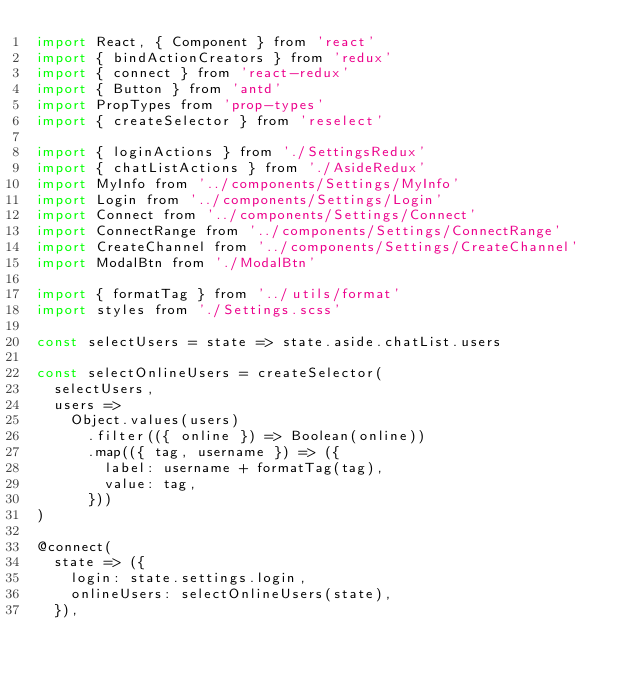<code> <loc_0><loc_0><loc_500><loc_500><_JavaScript_>import React, { Component } from 'react'
import { bindActionCreators } from 'redux'
import { connect } from 'react-redux'
import { Button } from 'antd'
import PropTypes from 'prop-types'
import { createSelector } from 'reselect'

import { loginActions } from './SettingsRedux'
import { chatListActions } from './AsideRedux'
import MyInfo from '../components/Settings/MyInfo'
import Login from '../components/Settings/Login'
import Connect from '../components/Settings/Connect'
import ConnectRange from '../components/Settings/ConnectRange'
import CreateChannel from '../components/Settings/CreateChannel'
import ModalBtn from './ModalBtn'

import { formatTag } from '../utils/format'
import styles from './Settings.scss'

const selectUsers = state => state.aside.chatList.users

const selectOnlineUsers = createSelector(
  selectUsers,
  users =>
    Object.values(users)
      .filter(({ online }) => Boolean(online))
      .map(({ tag, username }) => ({
        label: username + formatTag(tag),
        value: tag,
      }))
)

@connect(
  state => ({
    login: state.settings.login,
    onlineUsers: selectOnlineUsers(state),
  }),</code> 